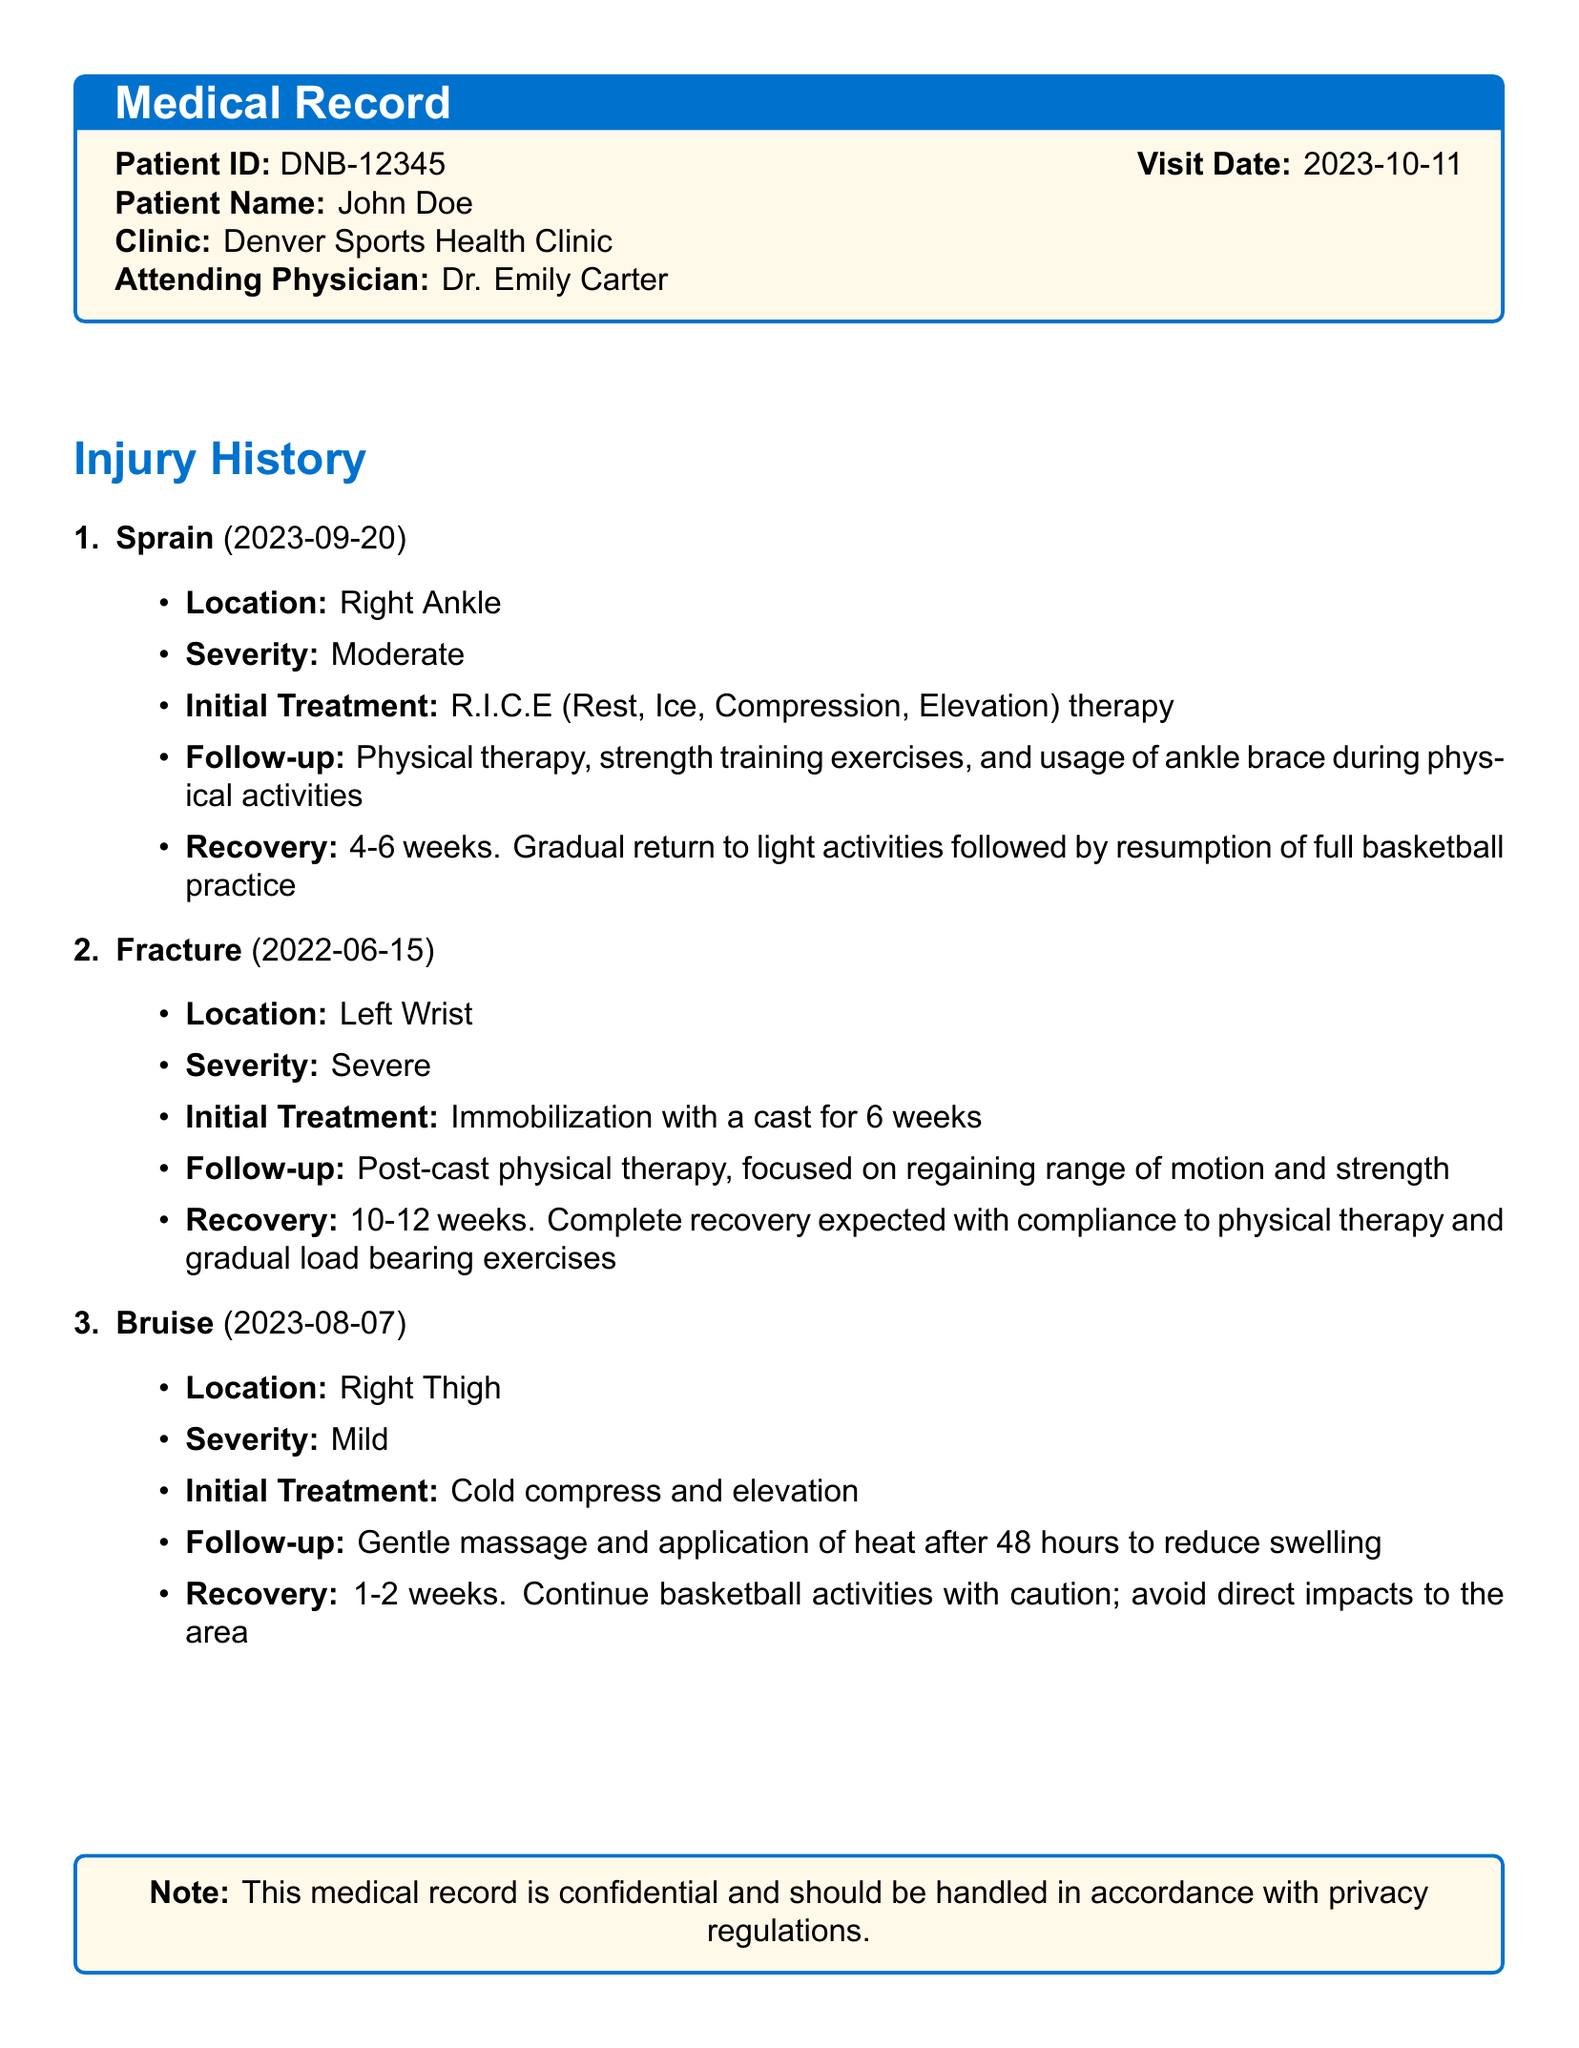what is the patient ID? The patient ID is mentioned at the beginning of the document under the medical record section as DNB-12345.
Answer: DNB-12345 who is the attending physician? The attending physician's name is provided in the medical record as Dr. Emily Carter.
Answer: Dr. Emily Carter when did the patient suffer a sprain? The date of the sprain is found in the injury history section and is noted as 2023-09-20.
Answer: 2023-09-20 what initial treatment was given for the fracture? The initial treatment for the fracture is detailed in the document as immobilization with a cast for 6 weeks.
Answer: immobilization with a cast for 6 weeks how long is the recovery period for the bruise? The recovery period for the bruise is indicated in the document as 1-2 weeks.
Answer: 1-2 weeks what is the severity of the left wrist fracture? The severity of the left wrist fracture is explicitly stated in the document as severe.
Answer: severe what follow-up treatment is suggested for the ankle sprain? The follow-up treatment for the ankle sprain is listed in the injury history as physical therapy, strength training exercises, and usage of an ankle brace during activities.
Answer: physical therapy, strength training exercises, and usage of ankle brace how long does full recovery take for the left wrist fracture after compliance? The document specifies that a complete recovery is expected in 10-12 weeks with compliance to physical therapy.
Answer: 10-12 weeks what advice is given for activities after recovering from the bruise? The document advises to continue basketball activities with caution and avoid direct impacts to the area after recovery from the bruise.
Answer: continue basketball activities with caution; avoid direct impacts 